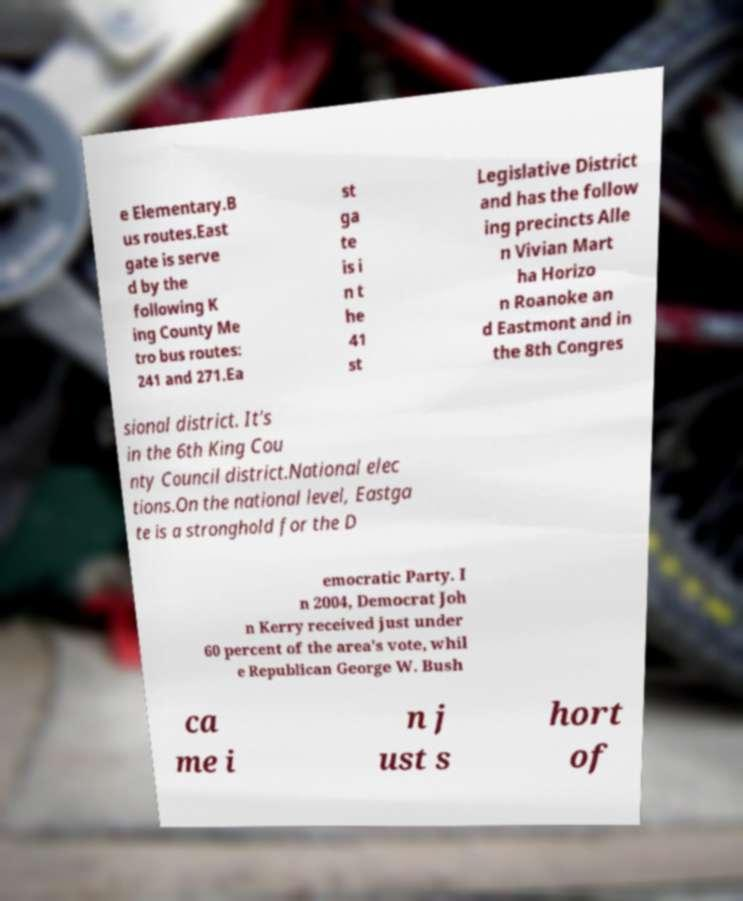Could you assist in decoding the text presented in this image and type it out clearly? e Elementary.B us routes.East gate is serve d by the following K ing County Me tro bus routes: 241 and 271.Ea st ga te is i n t he 41 st Legislative District and has the follow ing precincts Alle n Vivian Mart ha Horizo n Roanoke an d Eastmont and in the 8th Congres sional district. It's in the 6th King Cou nty Council district.National elec tions.On the national level, Eastga te is a stronghold for the D emocratic Party. I n 2004, Democrat Joh n Kerry received just under 60 percent of the area's vote, whil e Republican George W. Bush ca me i n j ust s hort of 